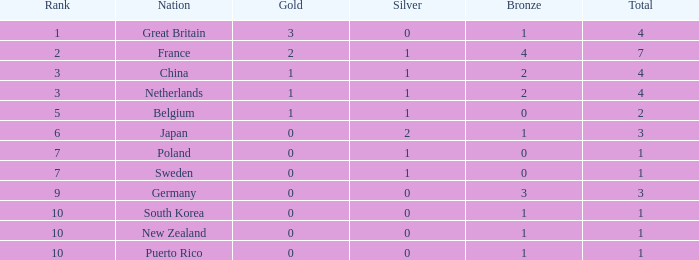What is the standing with no bronze medals? None. 